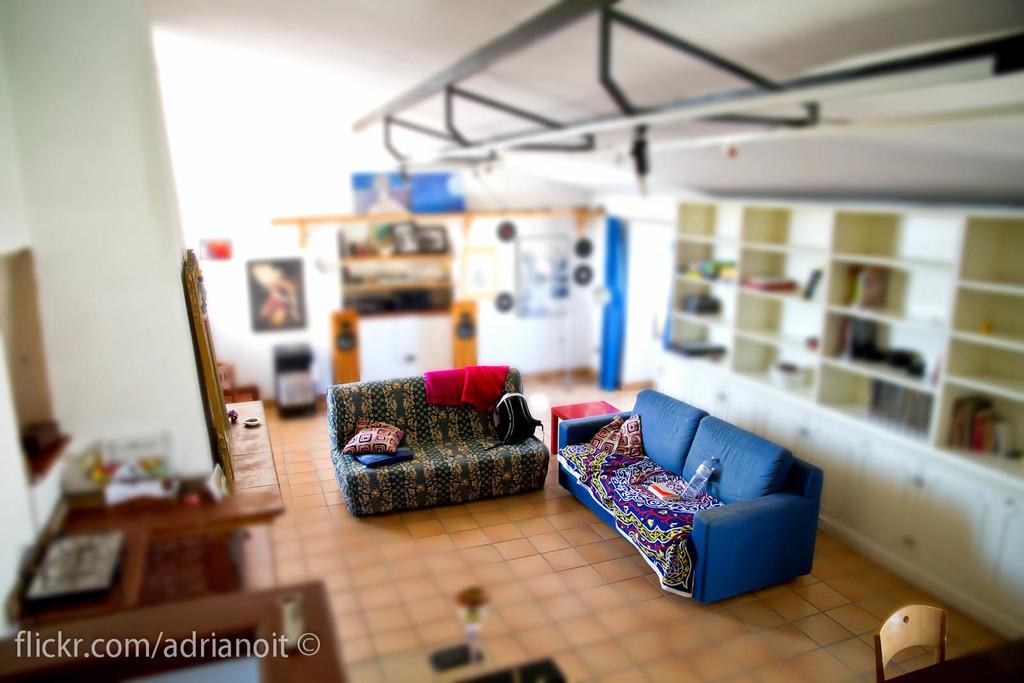<image>
Share a concise interpretation of the image provided. A living room that appears to be made of miniatures was featured on a flickr.com page. 